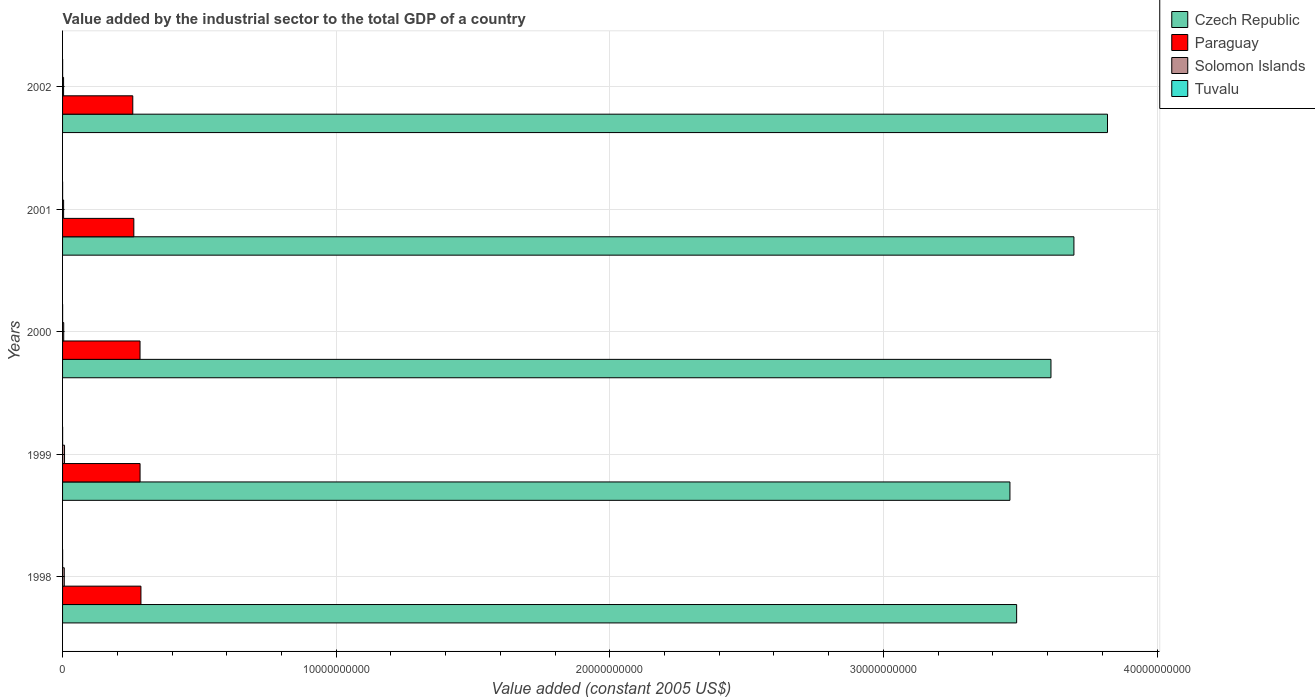How many different coloured bars are there?
Make the answer very short. 4. How many groups of bars are there?
Your response must be concise. 5. Are the number of bars per tick equal to the number of legend labels?
Offer a terse response. Yes. How many bars are there on the 5th tick from the top?
Ensure brevity in your answer.  4. What is the label of the 2nd group of bars from the top?
Your answer should be compact. 2001. What is the value added by the industrial sector in Tuvalu in 1998?
Keep it short and to the point. 1.39e+06. Across all years, what is the maximum value added by the industrial sector in Paraguay?
Your answer should be very brief. 2.86e+09. Across all years, what is the minimum value added by the industrial sector in Czech Republic?
Make the answer very short. 3.46e+1. In which year was the value added by the industrial sector in Czech Republic maximum?
Keep it short and to the point. 2002. What is the total value added by the industrial sector in Czech Republic in the graph?
Provide a succinct answer. 1.81e+11. What is the difference between the value added by the industrial sector in Solomon Islands in 1999 and that in 2002?
Offer a terse response. 3.46e+07. What is the difference between the value added by the industrial sector in Tuvalu in 1998 and the value added by the industrial sector in Solomon Islands in 2001?
Provide a short and direct response. -3.66e+07. What is the average value added by the industrial sector in Czech Republic per year?
Make the answer very short. 3.62e+1. In the year 1998, what is the difference between the value added by the industrial sector in Solomon Islands and value added by the industrial sector in Paraguay?
Your answer should be compact. -2.80e+09. In how many years, is the value added by the industrial sector in Czech Republic greater than 38000000000 US$?
Your answer should be very brief. 1. What is the ratio of the value added by the industrial sector in Tuvalu in 1999 to that in 2002?
Keep it short and to the point. 0.65. What is the difference between the highest and the second highest value added by the industrial sector in Czech Republic?
Provide a succinct answer. 1.23e+09. What is the difference between the highest and the lowest value added by the industrial sector in Czech Republic?
Offer a terse response. 3.57e+09. Is it the case that in every year, the sum of the value added by the industrial sector in Tuvalu and value added by the industrial sector in Solomon Islands is greater than the sum of value added by the industrial sector in Paraguay and value added by the industrial sector in Czech Republic?
Ensure brevity in your answer.  No. What does the 3rd bar from the top in 1999 represents?
Your answer should be very brief. Paraguay. What does the 4th bar from the bottom in 1998 represents?
Your response must be concise. Tuvalu. Are all the bars in the graph horizontal?
Your answer should be very brief. Yes. Are the values on the major ticks of X-axis written in scientific E-notation?
Keep it short and to the point. No. Does the graph contain any zero values?
Give a very brief answer. No. Where does the legend appear in the graph?
Ensure brevity in your answer.  Top right. What is the title of the graph?
Your answer should be very brief. Value added by the industrial sector to the total GDP of a country. Does "Greece" appear as one of the legend labels in the graph?
Keep it short and to the point. No. What is the label or title of the X-axis?
Your answer should be very brief. Value added (constant 2005 US$). What is the Value added (constant 2005 US$) of Czech Republic in 1998?
Provide a short and direct response. 3.49e+1. What is the Value added (constant 2005 US$) of Paraguay in 1998?
Provide a short and direct response. 2.86e+09. What is the Value added (constant 2005 US$) in Solomon Islands in 1998?
Your answer should be very brief. 6.18e+07. What is the Value added (constant 2005 US$) in Tuvalu in 1998?
Keep it short and to the point. 1.39e+06. What is the Value added (constant 2005 US$) in Czech Republic in 1999?
Ensure brevity in your answer.  3.46e+1. What is the Value added (constant 2005 US$) of Paraguay in 1999?
Ensure brevity in your answer.  2.83e+09. What is the Value added (constant 2005 US$) of Solomon Islands in 1999?
Offer a very short reply. 7.16e+07. What is the Value added (constant 2005 US$) of Tuvalu in 1999?
Keep it short and to the point. 1.40e+06. What is the Value added (constant 2005 US$) of Czech Republic in 2000?
Your answer should be very brief. 3.61e+1. What is the Value added (constant 2005 US$) of Paraguay in 2000?
Ensure brevity in your answer.  2.83e+09. What is the Value added (constant 2005 US$) of Solomon Islands in 2000?
Your answer should be very brief. 4.19e+07. What is the Value added (constant 2005 US$) of Tuvalu in 2000?
Give a very brief answer. 1.58e+06. What is the Value added (constant 2005 US$) of Czech Republic in 2001?
Keep it short and to the point. 3.70e+1. What is the Value added (constant 2005 US$) of Paraguay in 2001?
Make the answer very short. 2.60e+09. What is the Value added (constant 2005 US$) of Solomon Islands in 2001?
Ensure brevity in your answer.  3.80e+07. What is the Value added (constant 2005 US$) of Tuvalu in 2001?
Keep it short and to the point. 1.67e+06. What is the Value added (constant 2005 US$) in Czech Republic in 2002?
Keep it short and to the point. 3.82e+1. What is the Value added (constant 2005 US$) of Paraguay in 2002?
Make the answer very short. 2.57e+09. What is the Value added (constant 2005 US$) of Solomon Islands in 2002?
Make the answer very short. 3.70e+07. What is the Value added (constant 2005 US$) of Tuvalu in 2002?
Keep it short and to the point. 2.15e+06. Across all years, what is the maximum Value added (constant 2005 US$) of Czech Republic?
Your response must be concise. 3.82e+1. Across all years, what is the maximum Value added (constant 2005 US$) of Paraguay?
Make the answer very short. 2.86e+09. Across all years, what is the maximum Value added (constant 2005 US$) of Solomon Islands?
Keep it short and to the point. 7.16e+07. Across all years, what is the maximum Value added (constant 2005 US$) of Tuvalu?
Provide a succinct answer. 2.15e+06. Across all years, what is the minimum Value added (constant 2005 US$) of Czech Republic?
Your response must be concise. 3.46e+1. Across all years, what is the minimum Value added (constant 2005 US$) of Paraguay?
Offer a very short reply. 2.57e+09. Across all years, what is the minimum Value added (constant 2005 US$) in Solomon Islands?
Give a very brief answer. 3.70e+07. Across all years, what is the minimum Value added (constant 2005 US$) in Tuvalu?
Ensure brevity in your answer.  1.39e+06. What is the total Value added (constant 2005 US$) in Czech Republic in the graph?
Keep it short and to the point. 1.81e+11. What is the total Value added (constant 2005 US$) in Paraguay in the graph?
Offer a terse response. 1.37e+1. What is the total Value added (constant 2005 US$) of Solomon Islands in the graph?
Ensure brevity in your answer.  2.50e+08. What is the total Value added (constant 2005 US$) in Tuvalu in the graph?
Give a very brief answer. 8.18e+06. What is the difference between the Value added (constant 2005 US$) in Czech Republic in 1998 and that in 1999?
Provide a short and direct response. 2.45e+08. What is the difference between the Value added (constant 2005 US$) of Paraguay in 1998 and that in 1999?
Offer a terse response. 3.20e+07. What is the difference between the Value added (constant 2005 US$) in Solomon Islands in 1998 and that in 1999?
Your answer should be compact. -9.77e+06. What is the difference between the Value added (constant 2005 US$) in Tuvalu in 1998 and that in 1999?
Provide a short and direct response. -1.10e+04. What is the difference between the Value added (constant 2005 US$) in Czech Republic in 1998 and that in 2000?
Your answer should be compact. -1.25e+09. What is the difference between the Value added (constant 2005 US$) of Paraguay in 1998 and that in 2000?
Provide a short and direct response. 3.33e+07. What is the difference between the Value added (constant 2005 US$) of Solomon Islands in 1998 and that in 2000?
Your answer should be compact. 2.00e+07. What is the difference between the Value added (constant 2005 US$) in Tuvalu in 1998 and that in 2000?
Offer a terse response. -1.96e+05. What is the difference between the Value added (constant 2005 US$) in Czech Republic in 1998 and that in 2001?
Offer a terse response. -2.09e+09. What is the difference between the Value added (constant 2005 US$) of Paraguay in 1998 and that in 2001?
Your response must be concise. 2.60e+08. What is the difference between the Value added (constant 2005 US$) in Solomon Islands in 1998 and that in 2001?
Provide a short and direct response. 2.39e+07. What is the difference between the Value added (constant 2005 US$) in Tuvalu in 1998 and that in 2001?
Give a very brief answer. -2.80e+05. What is the difference between the Value added (constant 2005 US$) in Czech Republic in 1998 and that in 2002?
Ensure brevity in your answer.  -3.32e+09. What is the difference between the Value added (constant 2005 US$) of Paraguay in 1998 and that in 2002?
Make the answer very short. 2.98e+08. What is the difference between the Value added (constant 2005 US$) of Solomon Islands in 1998 and that in 2002?
Your answer should be very brief. 2.48e+07. What is the difference between the Value added (constant 2005 US$) in Tuvalu in 1998 and that in 2002?
Provide a short and direct response. -7.61e+05. What is the difference between the Value added (constant 2005 US$) in Czech Republic in 1999 and that in 2000?
Keep it short and to the point. -1.50e+09. What is the difference between the Value added (constant 2005 US$) of Paraguay in 1999 and that in 2000?
Ensure brevity in your answer.  1.33e+06. What is the difference between the Value added (constant 2005 US$) in Solomon Islands in 1999 and that in 2000?
Give a very brief answer. 2.97e+07. What is the difference between the Value added (constant 2005 US$) in Tuvalu in 1999 and that in 2000?
Offer a terse response. -1.85e+05. What is the difference between the Value added (constant 2005 US$) of Czech Republic in 1999 and that in 2001?
Your answer should be compact. -2.34e+09. What is the difference between the Value added (constant 2005 US$) of Paraguay in 1999 and that in 2001?
Offer a terse response. 2.28e+08. What is the difference between the Value added (constant 2005 US$) of Solomon Islands in 1999 and that in 2001?
Ensure brevity in your answer.  3.36e+07. What is the difference between the Value added (constant 2005 US$) of Tuvalu in 1999 and that in 2001?
Offer a terse response. -2.69e+05. What is the difference between the Value added (constant 2005 US$) in Czech Republic in 1999 and that in 2002?
Provide a short and direct response. -3.57e+09. What is the difference between the Value added (constant 2005 US$) of Paraguay in 1999 and that in 2002?
Offer a terse response. 2.66e+08. What is the difference between the Value added (constant 2005 US$) of Solomon Islands in 1999 and that in 2002?
Offer a very short reply. 3.46e+07. What is the difference between the Value added (constant 2005 US$) of Tuvalu in 1999 and that in 2002?
Keep it short and to the point. -7.50e+05. What is the difference between the Value added (constant 2005 US$) in Czech Republic in 2000 and that in 2001?
Keep it short and to the point. -8.39e+08. What is the difference between the Value added (constant 2005 US$) of Paraguay in 2000 and that in 2001?
Ensure brevity in your answer.  2.27e+08. What is the difference between the Value added (constant 2005 US$) in Solomon Islands in 2000 and that in 2001?
Keep it short and to the point. 3.89e+06. What is the difference between the Value added (constant 2005 US$) in Tuvalu in 2000 and that in 2001?
Provide a short and direct response. -8.40e+04. What is the difference between the Value added (constant 2005 US$) in Czech Republic in 2000 and that in 2002?
Ensure brevity in your answer.  -2.07e+09. What is the difference between the Value added (constant 2005 US$) in Paraguay in 2000 and that in 2002?
Offer a terse response. 2.65e+08. What is the difference between the Value added (constant 2005 US$) of Solomon Islands in 2000 and that in 2002?
Your answer should be very brief. 4.82e+06. What is the difference between the Value added (constant 2005 US$) in Tuvalu in 2000 and that in 2002?
Ensure brevity in your answer.  -5.64e+05. What is the difference between the Value added (constant 2005 US$) in Czech Republic in 2001 and that in 2002?
Keep it short and to the point. -1.23e+09. What is the difference between the Value added (constant 2005 US$) of Paraguay in 2001 and that in 2002?
Your answer should be compact. 3.84e+07. What is the difference between the Value added (constant 2005 US$) in Solomon Islands in 2001 and that in 2002?
Give a very brief answer. 9.35e+05. What is the difference between the Value added (constant 2005 US$) of Tuvalu in 2001 and that in 2002?
Provide a succinct answer. -4.80e+05. What is the difference between the Value added (constant 2005 US$) of Czech Republic in 1998 and the Value added (constant 2005 US$) of Paraguay in 1999?
Keep it short and to the point. 3.20e+1. What is the difference between the Value added (constant 2005 US$) of Czech Republic in 1998 and the Value added (constant 2005 US$) of Solomon Islands in 1999?
Provide a short and direct response. 3.48e+1. What is the difference between the Value added (constant 2005 US$) of Czech Republic in 1998 and the Value added (constant 2005 US$) of Tuvalu in 1999?
Ensure brevity in your answer.  3.49e+1. What is the difference between the Value added (constant 2005 US$) in Paraguay in 1998 and the Value added (constant 2005 US$) in Solomon Islands in 1999?
Provide a succinct answer. 2.79e+09. What is the difference between the Value added (constant 2005 US$) of Paraguay in 1998 and the Value added (constant 2005 US$) of Tuvalu in 1999?
Offer a very short reply. 2.86e+09. What is the difference between the Value added (constant 2005 US$) of Solomon Islands in 1998 and the Value added (constant 2005 US$) of Tuvalu in 1999?
Offer a very short reply. 6.05e+07. What is the difference between the Value added (constant 2005 US$) of Czech Republic in 1998 and the Value added (constant 2005 US$) of Paraguay in 2000?
Your response must be concise. 3.20e+1. What is the difference between the Value added (constant 2005 US$) in Czech Republic in 1998 and the Value added (constant 2005 US$) in Solomon Islands in 2000?
Offer a terse response. 3.48e+1. What is the difference between the Value added (constant 2005 US$) in Czech Republic in 1998 and the Value added (constant 2005 US$) in Tuvalu in 2000?
Your response must be concise. 3.49e+1. What is the difference between the Value added (constant 2005 US$) of Paraguay in 1998 and the Value added (constant 2005 US$) of Solomon Islands in 2000?
Make the answer very short. 2.82e+09. What is the difference between the Value added (constant 2005 US$) in Paraguay in 1998 and the Value added (constant 2005 US$) in Tuvalu in 2000?
Your answer should be compact. 2.86e+09. What is the difference between the Value added (constant 2005 US$) in Solomon Islands in 1998 and the Value added (constant 2005 US$) in Tuvalu in 2000?
Offer a terse response. 6.03e+07. What is the difference between the Value added (constant 2005 US$) in Czech Republic in 1998 and the Value added (constant 2005 US$) in Paraguay in 2001?
Ensure brevity in your answer.  3.23e+1. What is the difference between the Value added (constant 2005 US$) of Czech Republic in 1998 and the Value added (constant 2005 US$) of Solomon Islands in 2001?
Keep it short and to the point. 3.48e+1. What is the difference between the Value added (constant 2005 US$) in Czech Republic in 1998 and the Value added (constant 2005 US$) in Tuvalu in 2001?
Ensure brevity in your answer.  3.49e+1. What is the difference between the Value added (constant 2005 US$) of Paraguay in 1998 and the Value added (constant 2005 US$) of Solomon Islands in 2001?
Your response must be concise. 2.83e+09. What is the difference between the Value added (constant 2005 US$) of Paraguay in 1998 and the Value added (constant 2005 US$) of Tuvalu in 2001?
Your answer should be very brief. 2.86e+09. What is the difference between the Value added (constant 2005 US$) of Solomon Islands in 1998 and the Value added (constant 2005 US$) of Tuvalu in 2001?
Provide a short and direct response. 6.02e+07. What is the difference between the Value added (constant 2005 US$) in Czech Republic in 1998 and the Value added (constant 2005 US$) in Paraguay in 2002?
Provide a succinct answer. 3.23e+1. What is the difference between the Value added (constant 2005 US$) in Czech Republic in 1998 and the Value added (constant 2005 US$) in Solomon Islands in 2002?
Ensure brevity in your answer.  3.48e+1. What is the difference between the Value added (constant 2005 US$) in Czech Republic in 1998 and the Value added (constant 2005 US$) in Tuvalu in 2002?
Make the answer very short. 3.49e+1. What is the difference between the Value added (constant 2005 US$) in Paraguay in 1998 and the Value added (constant 2005 US$) in Solomon Islands in 2002?
Offer a terse response. 2.83e+09. What is the difference between the Value added (constant 2005 US$) in Paraguay in 1998 and the Value added (constant 2005 US$) in Tuvalu in 2002?
Keep it short and to the point. 2.86e+09. What is the difference between the Value added (constant 2005 US$) of Solomon Islands in 1998 and the Value added (constant 2005 US$) of Tuvalu in 2002?
Provide a succinct answer. 5.97e+07. What is the difference between the Value added (constant 2005 US$) of Czech Republic in 1999 and the Value added (constant 2005 US$) of Paraguay in 2000?
Give a very brief answer. 3.18e+1. What is the difference between the Value added (constant 2005 US$) in Czech Republic in 1999 and the Value added (constant 2005 US$) in Solomon Islands in 2000?
Your answer should be very brief. 3.46e+1. What is the difference between the Value added (constant 2005 US$) in Czech Republic in 1999 and the Value added (constant 2005 US$) in Tuvalu in 2000?
Ensure brevity in your answer.  3.46e+1. What is the difference between the Value added (constant 2005 US$) in Paraguay in 1999 and the Value added (constant 2005 US$) in Solomon Islands in 2000?
Keep it short and to the point. 2.79e+09. What is the difference between the Value added (constant 2005 US$) of Paraguay in 1999 and the Value added (constant 2005 US$) of Tuvalu in 2000?
Provide a short and direct response. 2.83e+09. What is the difference between the Value added (constant 2005 US$) of Solomon Islands in 1999 and the Value added (constant 2005 US$) of Tuvalu in 2000?
Your answer should be compact. 7.00e+07. What is the difference between the Value added (constant 2005 US$) in Czech Republic in 1999 and the Value added (constant 2005 US$) in Paraguay in 2001?
Keep it short and to the point. 3.20e+1. What is the difference between the Value added (constant 2005 US$) in Czech Republic in 1999 and the Value added (constant 2005 US$) in Solomon Islands in 2001?
Your response must be concise. 3.46e+1. What is the difference between the Value added (constant 2005 US$) of Czech Republic in 1999 and the Value added (constant 2005 US$) of Tuvalu in 2001?
Keep it short and to the point. 3.46e+1. What is the difference between the Value added (constant 2005 US$) in Paraguay in 1999 and the Value added (constant 2005 US$) in Solomon Islands in 2001?
Your response must be concise. 2.79e+09. What is the difference between the Value added (constant 2005 US$) in Paraguay in 1999 and the Value added (constant 2005 US$) in Tuvalu in 2001?
Provide a short and direct response. 2.83e+09. What is the difference between the Value added (constant 2005 US$) in Solomon Islands in 1999 and the Value added (constant 2005 US$) in Tuvalu in 2001?
Make the answer very short. 6.99e+07. What is the difference between the Value added (constant 2005 US$) of Czech Republic in 1999 and the Value added (constant 2005 US$) of Paraguay in 2002?
Offer a very short reply. 3.21e+1. What is the difference between the Value added (constant 2005 US$) of Czech Republic in 1999 and the Value added (constant 2005 US$) of Solomon Islands in 2002?
Keep it short and to the point. 3.46e+1. What is the difference between the Value added (constant 2005 US$) of Czech Republic in 1999 and the Value added (constant 2005 US$) of Tuvalu in 2002?
Offer a very short reply. 3.46e+1. What is the difference between the Value added (constant 2005 US$) of Paraguay in 1999 and the Value added (constant 2005 US$) of Solomon Islands in 2002?
Provide a short and direct response. 2.80e+09. What is the difference between the Value added (constant 2005 US$) in Paraguay in 1999 and the Value added (constant 2005 US$) in Tuvalu in 2002?
Keep it short and to the point. 2.83e+09. What is the difference between the Value added (constant 2005 US$) of Solomon Islands in 1999 and the Value added (constant 2005 US$) of Tuvalu in 2002?
Your answer should be very brief. 6.95e+07. What is the difference between the Value added (constant 2005 US$) in Czech Republic in 2000 and the Value added (constant 2005 US$) in Paraguay in 2001?
Provide a succinct answer. 3.35e+1. What is the difference between the Value added (constant 2005 US$) in Czech Republic in 2000 and the Value added (constant 2005 US$) in Solomon Islands in 2001?
Keep it short and to the point. 3.61e+1. What is the difference between the Value added (constant 2005 US$) of Czech Republic in 2000 and the Value added (constant 2005 US$) of Tuvalu in 2001?
Offer a very short reply. 3.61e+1. What is the difference between the Value added (constant 2005 US$) in Paraguay in 2000 and the Value added (constant 2005 US$) in Solomon Islands in 2001?
Offer a terse response. 2.79e+09. What is the difference between the Value added (constant 2005 US$) in Paraguay in 2000 and the Value added (constant 2005 US$) in Tuvalu in 2001?
Ensure brevity in your answer.  2.83e+09. What is the difference between the Value added (constant 2005 US$) of Solomon Islands in 2000 and the Value added (constant 2005 US$) of Tuvalu in 2001?
Provide a succinct answer. 4.02e+07. What is the difference between the Value added (constant 2005 US$) of Czech Republic in 2000 and the Value added (constant 2005 US$) of Paraguay in 2002?
Provide a succinct answer. 3.36e+1. What is the difference between the Value added (constant 2005 US$) in Czech Republic in 2000 and the Value added (constant 2005 US$) in Solomon Islands in 2002?
Offer a terse response. 3.61e+1. What is the difference between the Value added (constant 2005 US$) in Czech Republic in 2000 and the Value added (constant 2005 US$) in Tuvalu in 2002?
Provide a short and direct response. 3.61e+1. What is the difference between the Value added (constant 2005 US$) of Paraguay in 2000 and the Value added (constant 2005 US$) of Solomon Islands in 2002?
Provide a short and direct response. 2.79e+09. What is the difference between the Value added (constant 2005 US$) of Paraguay in 2000 and the Value added (constant 2005 US$) of Tuvalu in 2002?
Your answer should be very brief. 2.83e+09. What is the difference between the Value added (constant 2005 US$) in Solomon Islands in 2000 and the Value added (constant 2005 US$) in Tuvalu in 2002?
Your response must be concise. 3.97e+07. What is the difference between the Value added (constant 2005 US$) in Czech Republic in 2001 and the Value added (constant 2005 US$) in Paraguay in 2002?
Your answer should be very brief. 3.44e+1. What is the difference between the Value added (constant 2005 US$) in Czech Republic in 2001 and the Value added (constant 2005 US$) in Solomon Islands in 2002?
Offer a very short reply. 3.69e+1. What is the difference between the Value added (constant 2005 US$) in Czech Republic in 2001 and the Value added (constant 2005 US$) in Tuvalu in 2002?
Give a very brief answer. 3.70e+1. What is the difference between the Value added (constant 2005 US$) in Paraguay in 2001 and the Value added (constant 2005 US$) in Solomon Islands in 2002?
Ensure brevity in your answer.  2.57e+09. What is the difference between the Value added (constant 2005 US$) in Paraguay in 2001 and the Value added (constant 2005 US$) in Tuvalu in 2002?
Ensure brevity in your answer.  2.60e+09. What is the difference between the Value added (constant 2005 US$) of Solomon Islands in 2001 and the Value added (constant 2005 US$) of Tuvalu in 2002?
Keep it short and to the point. 3.58e+07. What is the average Value added (constant 2005 US$) of Czech Republic per year?
Provide a short and direct response. 3.62e+1. What is the average Value added (constant 2005 US$) in Paraguay per year?
Your answer should be compact. 2.74e+09. What is the average Value added (constant 2005 US$) of Solomon Islands per year?
Ensure brevity in your answer.  5.01e+07. What is the average Value added (constant 2005 US$) of Tuvalu per year?
Your response must be concise. 1.64e+06. In the year 1998, what is the difference between the Value added (constant 2005 US$) in Czech Republic and Value added (constant 2005 US$) in Paraguay?
Your answer should be very brief. 3.20e+1. In the year 1998, what is the difference between the Value added (constant 2005 US$) of Czech Republic and Value added (constant 2005 US$) of Solomon Islands?
Offer a very short reply. 3.48e+1. In the year 1998, what is the difference between the Value added (constant 2005 US$) of Czech Republic and Value added (constant 2005 US$) of Tuvalu?
Ensure brevity in your answer.  3.49e+1. In the year 1998, what is the difference between the Value added (constant 2005 US$) of Paraguay and Value added (constant 2005 US$) of Solomon Islands?
Keep it short and to the point. 2.80e+09. In the year 1998, what is the difference between the Value added (constant 2005 US$) of Paraguay and Value added (constant 2005 US$) of Tuvalu?
Ensure brevity in your answer.  2.86e+09. In the year 1998, what is the difference between the Value added (constant 2005 US$) in Solomon Islands and Value added (constant 2005 US$) in Tuvalu?
Your response must be concise. 6.05e+07. In the year 1999, what is the difference between the Value added (constant 2005 US$) in Czech Republic and Value added (constant 2005 US$) in Paraguay?
Offer a very short reply. 3.18e+1. In the year 1999, what is the difference between the Value added (constant 2005 US$) in Czech Republic and Value added (constant 2005 US$) in Solomon Islands?
Keep it short and to the point. 3.46e+1. In the year 1999, what is the difference between the Value added (constant 2005 US$) of Czech Republic and Value added (constant 2005 US$) of Tuvalu?
Your answer should be very brief. 3.46e+1. In the year 1999, what is the difference between the Value added (constant 2005 US$) in Paraguay and Value added (constant 2005 US$) in Solomon Islands?
Your response must be concise. 2.76e+09. In the year 1999, what is the difference between the Value added (constant 2005 US$) of Paraguay and Value added (constant 2005 US$) of Tuvalu?
Make the answer very short. 2.83e+09. In the year 1999, what is the difference between the Value added (constant 2005 US$) of Solomon Islands and Value added (constant 2005 US$) of Tuvalu?
Offer a terse response. 7.02e+07. In the year 2000, what is the difference between the Value added (constant 2005 US$) in Czech Republic and Value added (constant 2005 US$) in Paraguay?
Give a very brief answer. 3.33e+1. In the year 2000, what is the difference between the Value added (constant 2005 US$) of Czech Republic and Value added (constant 2005 US$) of Solomon Islands?
Ensure brevity in your answer.  3.61e+1. In the year 2000, what is the difference between the Value added (constant 2005 US$) of Czech Republic and Value added (constant 2005 US$) of Tuvalu?
Make the answer very short. 3.61e+1. In the year 2000, what is the difference between the Value added (constant 2005 US$) of Paraguay and Value added (constant 2005 US$) of Solomon Islands?
Give a very brief answer. 2.79e+09. In the year 2000, what is the difference between the Value added (constant 2005 US$) in Paraguay and Value added (constant 2005 US$) in Tuvalu?
Provide a short and direct response. 2.83e+09. In the year 2000, what is the difference between the Value added (constant 2005 US$) of Solomon Islands and Value added (constant 2005 US$) of Tuvalu?
Provide a succinct answer. 4.03e+07. In the year 2001, what is the difference between the Value added (constant 2005 US$) of Czech Republic and Value added (constant 2005 US$) of Paraguay?
Offer a very short reply. 3.44e+1. In the year 2001, what is the difference between the Value added (constant 2005 US$) in Czech Republic and Value added (constant 2005 US$) in Solomon Islands?
Your response must be concise. 3.69e+1. In the year 2001, what is the difference between the Value added (constant 2005 US$) in Czech Republic and Value added (constant 2005 US$) in Tuvalu?
Provide a succinct answer. 3.70e+1. In the year 2001, what is the difference between the Value added (constant 2005 US$) in Paraguay and Value added (constant 2005 US$) in Solomon Islands?
Offer a very short reply. 2.57e+09. In the year 2001, what is the difference between the Value added (constant 2005 US$) of Paraguay and Value added (constant 2005 US$) of Tuvalu?
Make the answer very short. 2.60e+09. In the year 2001, what is the difference between the Value added (constant 2005 US$) of Solomon Islands and Value added (constant 2005 US$) of Tuvalu?
Ensure brevity in your answer.  3.63e+07. In the year 2002, what is the difference between the Value added (constant 2005 US$) in Czech Republic and Value added (constant 2005 US$) in Paraguay?
Keep it short and to the point. 3.56e+1. In the year 2002, what is the difference between the Value added (constant 2005 US$) of Czech Republic and Value added (constant 2005 US$) of Solomon Islands?
Offer a very short reply. 3.82e+1. In the year 2002, what is the difference between the Value added (constant 2005 US$) of Czech Republic and Value added (constant 2005 US$) of Tuvalu?
Make the answer very short. 3.82e+1. In the year 2002, what is the difference between the Value added (constant 2005 US$) in Paraguay and Value added (constant 2005 US$) in Solomon Islands?
Your answer should be very brief. 2.53e+09. In the year 2002, what is the difference between the Value added (constant 2005 US$) in Paraguay and Value added (constant 2005 US$) in Tuvalu?
Provide a succinct answer. 2.56e+09. In the year 2002, what is the difference between the Value added (constant 2005 US$) in Solomon Islands and Value added (constant 2005 US$) in Tuvalu?
Offer a very short reply. 3.49e+07. What is the ratio of the Value added (constant 2005 US$) of Czech Republic in 1998 to that in 1999?
Provide a short and direct response. 1.01. What is the ratio of the Value added (constant 2005 US$) in Paraguay in 1998 to that in 1999?
Give a very brief answer. 1.01. What is the ratio of the Value added (constant 2005 US$) of Solomon Islands in 1998 to that in 1999?
Offer a very short reply. 0.86. What is the ratio of the Value added (constant 2005 US$) in Tuvalu in 1998 to that in 1999?
Provide a short and direct response. 0.99. What is the ratio of the Value added (constant 2005 US$) in Czech Republic in 1998 to that in 2000?
Your answer should be compact. 0.97. What is the ratio of the Value added (constant 2005 US$) in Paraguay in 1998 to that in 2000?
Give a very brief answer. 1.01. What is the ratio of the Value added (constant 2005 US$) in Solomon Islands in 1998 to that in 2000?
Ensure brevity in your answer.  1.48. What is the ratio of the Value added (constant 2005 US$) in Tuvalu in 1998 to that in 2000?
Give a very brief answer. 0.88. What is the ratio of the Value added (constant 2005 US$) of Czech Republic in 1998 to that in 2001?
Your response must be concise. 0.94. What is the ratio of the Value added (constant 2005 US$) of Paraguay in 1998 to that in 2001?
Your answer should be compact. 1.1. What is the ratio of the Value added (constant 2005 US$) in Solomon Islands in 1998 to that in 2001?
Provide a short and direct response. 1.63. What is the ratio of the Value added (constant 2005 US$) in Tuvalu in 1998 to that in 2001?
Provide a short and direct response. 0.83. What is the ratio of the Value added (constant 2005 US$) of Czech Republic in 1998 to that in 2002?
Offer a very short reply. 0.91. What is the ratio of the Value added (constant 2005 US$) of Paraguay in 1998 to that in 2002?
Provide a short and direct response. 1.12. What is the ratio of the Value added (constant 2005 US$) of Solomon Islands in 1998 to that in 2002?
Offer a very short reply. 1.67. What is the ratio of the Value added (constant 2005 US$) in Tuvalu in 1998 to that in 2002?
Your response must be concise. 0.65. What is the ratio of the Value added (constant 2005 US$) in Czech Republic in 1999 to that in 2000?
Give a very brief answer. 0.96. What is the ratio of the Value added (constant 2005 US$) of Paraguay in 1999 to that in 2000?
Your answer should be compact. 1. What is the ratio of the Value added (constant 2005 US$) in Solomon Islands in 1999 to that in 2000?
Offer a terse response. 1.71. What is the ratio of the Value added (constant 2005 US$) of Tuvalu in 1999 to that in 2000?
Make the answer very short. 0.88. What is the ratio of the Value added (constant 2005 US$) of Czech Republic in 1999 to that in 2001?
Make the answer very short. 0.94. What is the ratio of the Value added (constant 2005 US$) in Paraguay in 1999 to that in 2001?
Provide a succinct answer. 1.09. What is the ratio of the Value added (constant 2005 US$) in Solomon Islands in 1999 to that in 2001?
Your response must be concise. 1.89. What is the ratio of the Value added (constant 2005 US$) in Tuvalu in 1999 to that in 2001?
Provide a succinct answer. 0.84. What is the ratio of the Value added (constant 2005 US$) of Czech Republic in 1999 to that in 2002?
Provide a short and direct response. 0.91. What is the ratio of the Value added (constant 2005 US$) in Paraguay in 1999 to that in 2002?
Offer a terse response. 1.1. What is the ratio of the Value added (constant 2005 US$) of Solomon Islands in 1999 to that in 2002?
Keep it short and to the point. 1.93. What is the ratio of the Value added (constant 2005 US$) in Tuvalu in 1999 to that in 2002?
Offer a very short reply. 0.65. What is the ratio of the Value added (constant 2005 US$) in Czech Republic in 2000 to that in 2001?
Your answer should be compact. 0.98. What is the ratio of the Value added (constant 2005 US$) of Paraguay in 2000 to that in 2001?
Provide a succinct answer. 1.09. What is the ratio of the Value added (constant 2005 US$) of Solomon Islands in 2000 to that in 2001?
Keep it short and to the point. 1.1. What is the ratio of the Value added (constant 2005 US$) of Tuvalu in 2000 to that in 2001?
Make the answer very short. 0.95. What is the ratio of the Value added (constant 2005 US$) in Czech Republic in 2000 to that in 2002?
Your answer should be very brief. 0.95. What is the ratio of the Value added (constant 2005 US$) of Paraguay in 2000 to that in 2002?
Your answer should be very brief. 1.1. What is the ratio of the Value added (constant 2005 US$) of Solomon Islands in 2000 to that in 2002?
Keep it short and to the point. 1.13. What is the ratio of the Value added (constant 2005 US$) of Tuvalu in 2000 to that in 2002?
Give a very brief answer. 0.74. What is the ratio of the Value added (constant 2005 US$) in Czech Republic in 2001 to that in 2002?
Give a very brief answer. 0.97. What is the ratio of the Value added (constant 2005 US$) in Paraguay in 2001 to that in 2002?
Keep it short and to the point. 1.01. What is the ratio of the Value added (constant 2005 US$) of Solomon Islands in 2001 to that in 2002?
Offer a terse response. 1.03. What is the ratio of the Value added (constant 2005 US$) of Tuvalu in 2001 to that in 2002?
Provide a short and direct response. 0.78. What is the difference between the highest and the second highest Value added (constant 2005 US$) in Czech Republic?
Ensure brevity in your answer.  1.23e+09. What is the difference between the highest and the second highest Value added (constant 2005 US$) in Paraguay?
Your response must be concise. 3.20e+07. What is the difference between the highest and the second highest Value added (constant 2005 US$) of Solomon Islands?
Offer a very short reply. 9.77e+06. What is the difference between the highest and the second highest Value added (constant 2005 US$) of Tuvalu?
Keep it short and to the point. 4.80e+05. What is the difference between the highest and the lowest Value added (constant 2005 US$) of Czech Republic?
Keep it short and to the point. 3.57e+09. What is the difference between the highest and the lowest Value added (constant 2005 US$) of Paraguay?
Offer a very short reply. 2.98e+08. What is the difference between the highest and the lowest Value added (constant 2005 US$) of Solomon Islands?
Make the answer very short. 3.46e+07. What is the difference between the highest and the lowest Value added (constant 2005 US$) in Tuvalu?
Your response must be concise. 7.61e+05. 